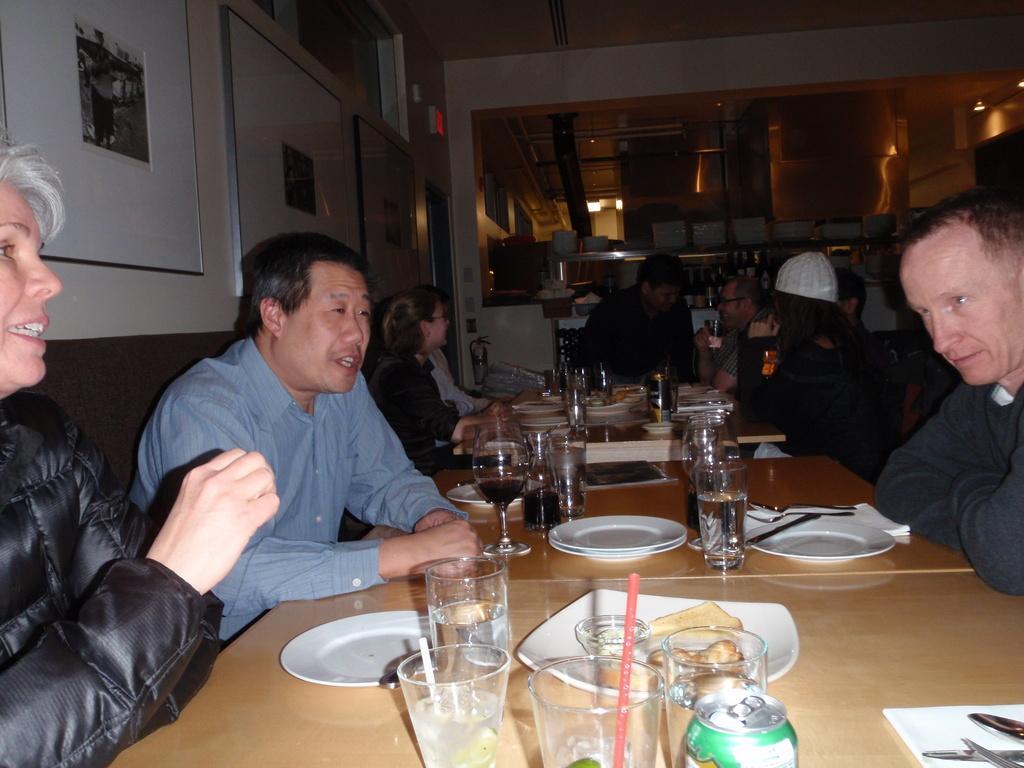Please provide a concise description of this image. Here we can see that a person is sitting on the chair, and in front there is the dining table and plates and glasses and some objects on it ,and at back here is the wall, and here there are group of people sitting. 